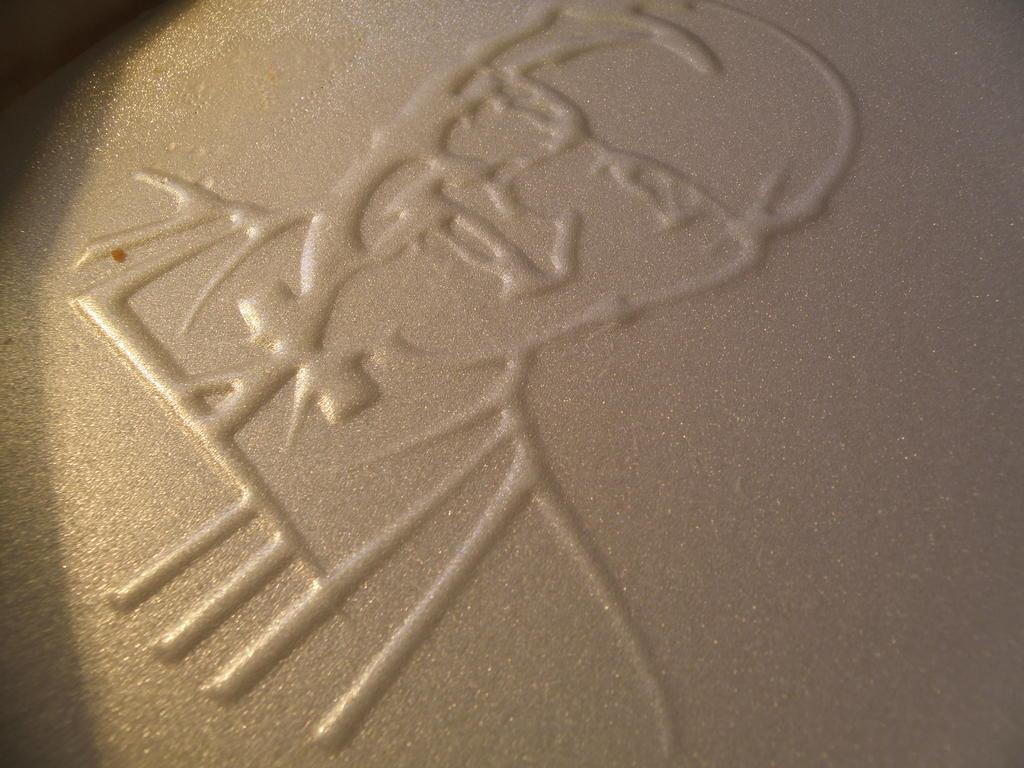Describe this image in one or two sentences. In this picture we can see art on the cream surface. 